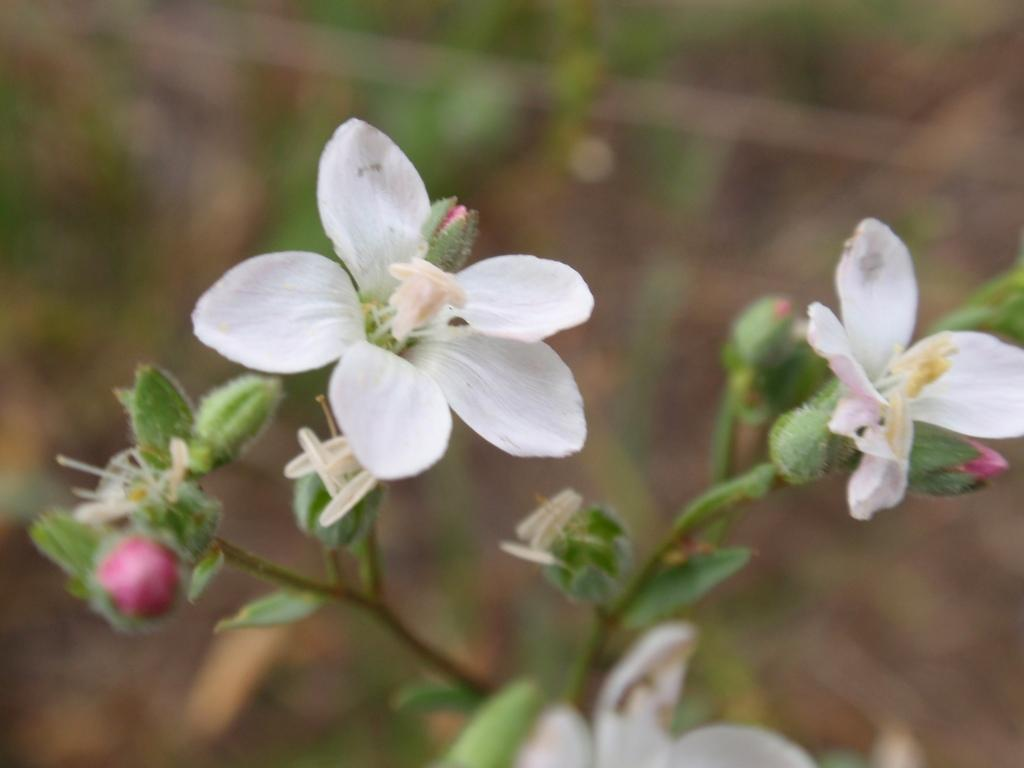What type of living organism is present in the image? There is a plant in the image. What specific feature can be seen on the plant? The plant has a flower. Are there any other parts of the plant that are not yet fully bloomed? Yes, the plant has buds. What is the color of the flowers on the plant? The flowers on the plant are white in color. What type of mouth can be seen on the plant in the image? There is no mouth present on the plant in the image, as plants do not have mouths. Can you tell me how the plant controls its growth in the image? Plants do not have the ability to control their growth consciously, as they are living organisms and not machines or robots. 